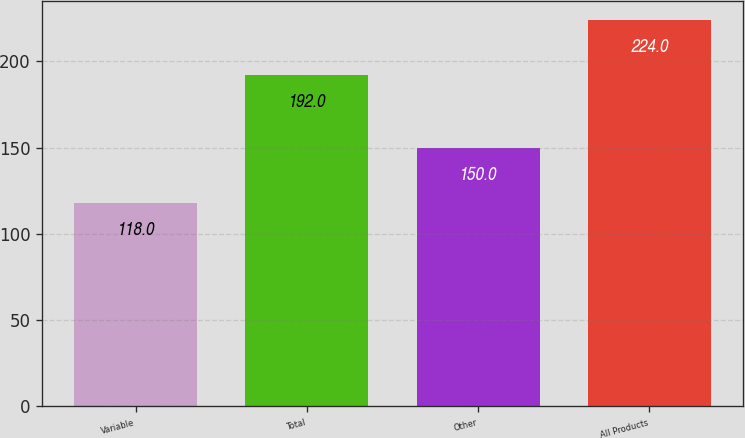Convert chart to OTSL. <chart><loc_0><loc_0><loc_500><loc_500><bar_chart><fcel>Variable<fcel>Total<fcel>Other<fcel>All Products<nl><fcel>118<fcel>192<fcel>150<fcel>224<nl></chart> 